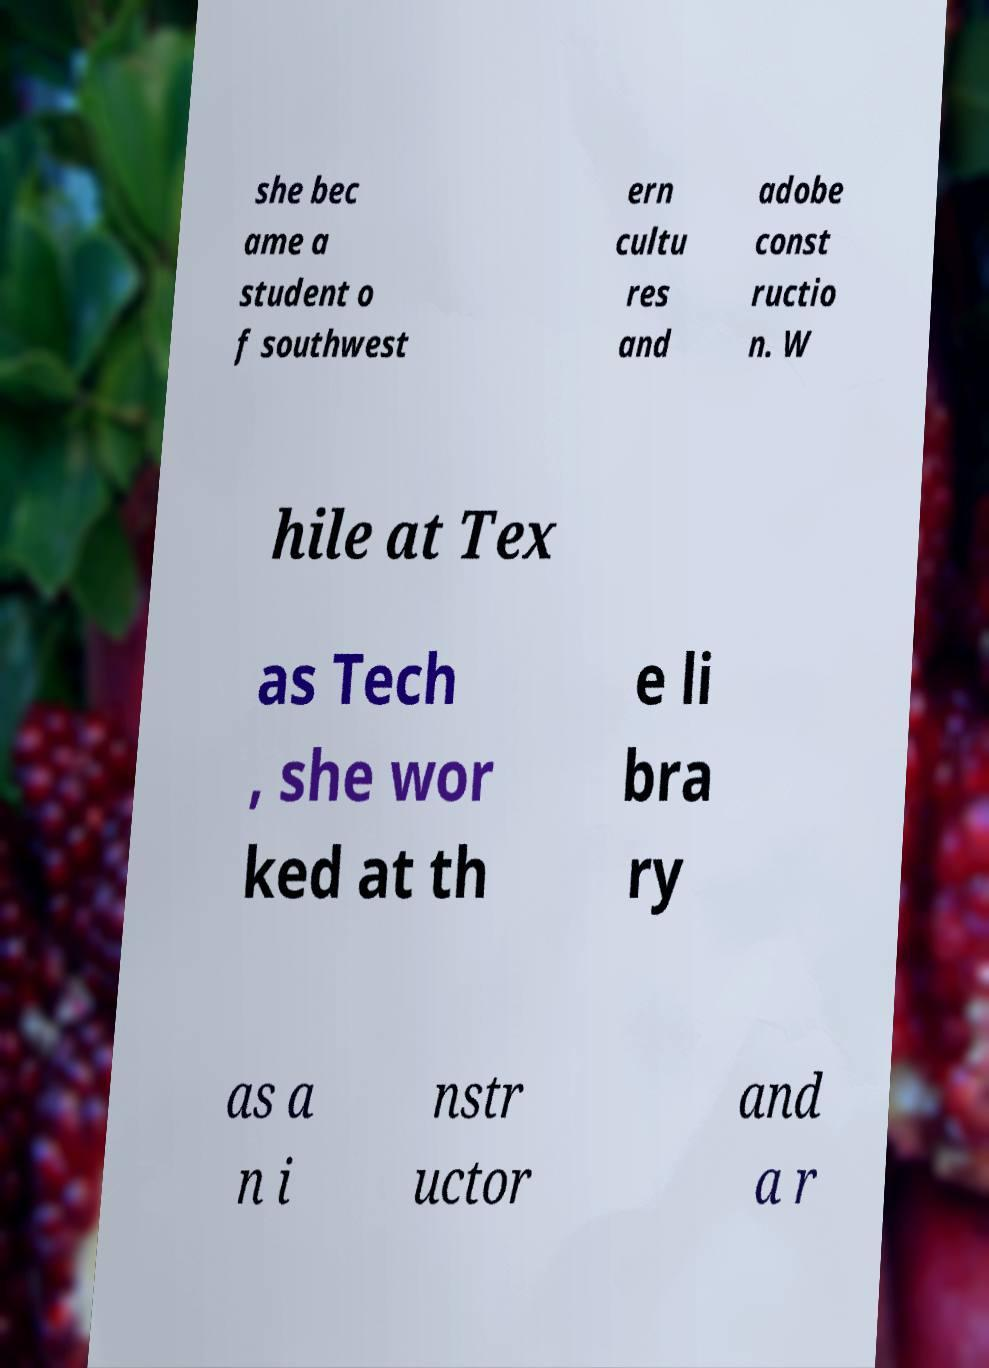Can you accurately transcribe the text from the provided image for me? she bec ame a student o f southwest ern cultu res and adobe const ructio n. W hile at Tex as Tech , she wor ked at th e li bra ry as a n i nstr uctor and a r 